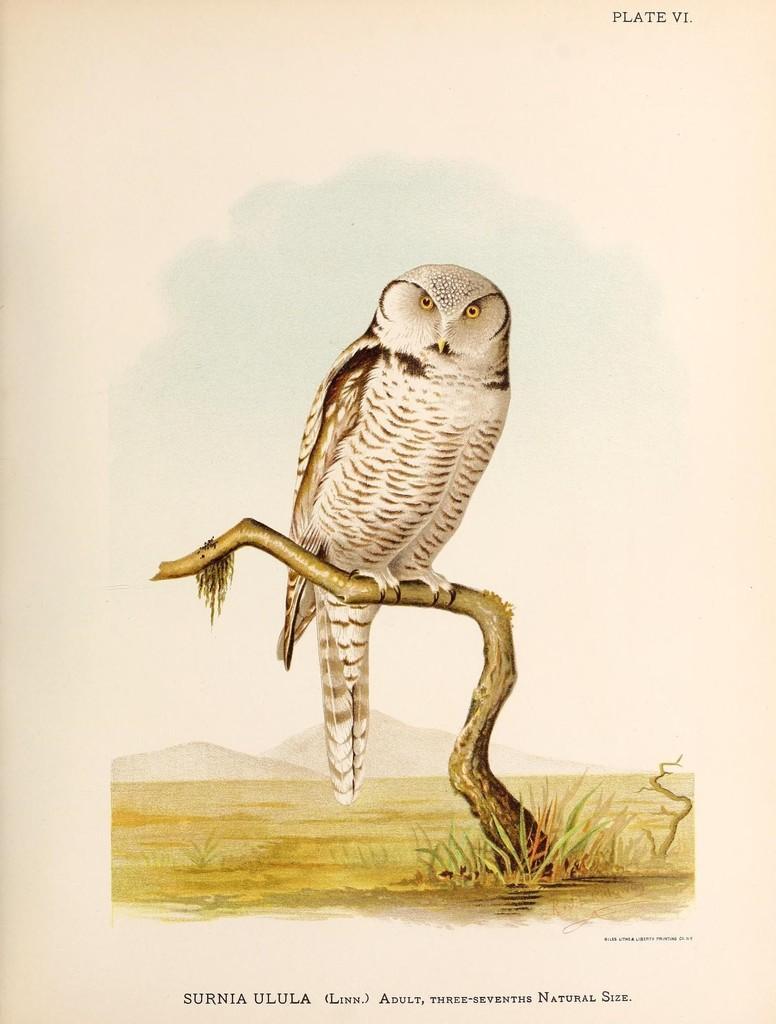Can you describe this image briefly? In the picture we can see the painting of the owl sitting on the branch of the tree and near it we can see some grass. 